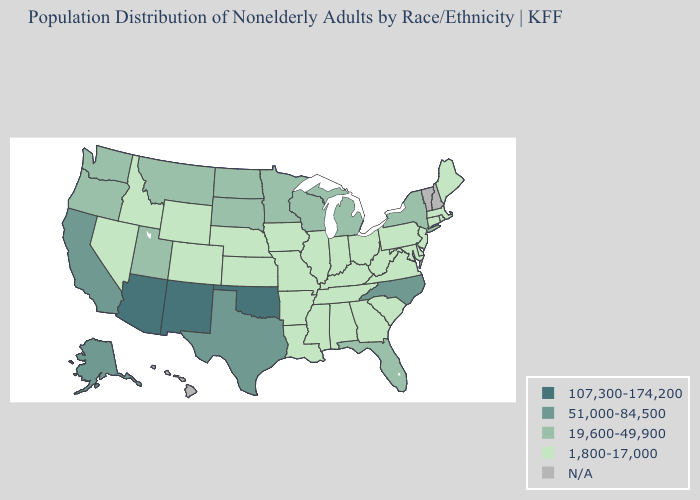What is the value of Indiana?
Give a very brief answer. 1,800-17,000. Name the states that have a value in the range 19,600-49,900?
Quick response, please. Florida, Michigan, Minnesota, Montana, New York, North Dakota, Oregon, South Dakota, Utah, Washington, Wisconsin. Name the states that have a value in the range 51,000-84,500?
Concise answer only. Alaska, California, North Carolina, Texas. What is the value of Texas?
Quick response, please. 51,000-84,500. Which states have the lowest value in the USA?
Give a very brief answer. Alabama, Arkansas, Colorado, Connecticut, Delaware, Georgia, Idaho, Illinois, Indiana, Iowa, Kansas, Kentucky, Louisiana, Maine, Maryland, Massachusetts, Mississippi, Missouri, Nebraska, Nevada, New Jersey, Ohio, Pennsylvania, Rhode Island, South Carolina, Tennessee, Virginia, West Virginia, Wyoming. What is the value of Iowa?
Keep it brief. 1,800-17,000. Does New York have the highest value in the Northeast?
Be succinct. Yes. Does Massachusetts have the lowest value in the Northeast?
Keep it brief. Yes. Among the states that border California , does Nevada have the lowest value?
Answer briefly. Yes. Among the states that border Florida , which have the highest value?
Quick response, please. Alabama, Georgia. What is the value of Montana?
Concise answer only. 19,600-49,900. How many symbols are there in the legend?
Keep it brief. 5. What is the highest value in states that border North Dakota?
Quick response, please. 19,600-49,900. Name the states that have a value in the range 51,000-84,500?
Give a very brief answer. Alaska, California, North Carolina, Texas. What is the value of Louisiana?
Concise answer only. 1,800-17,000. 